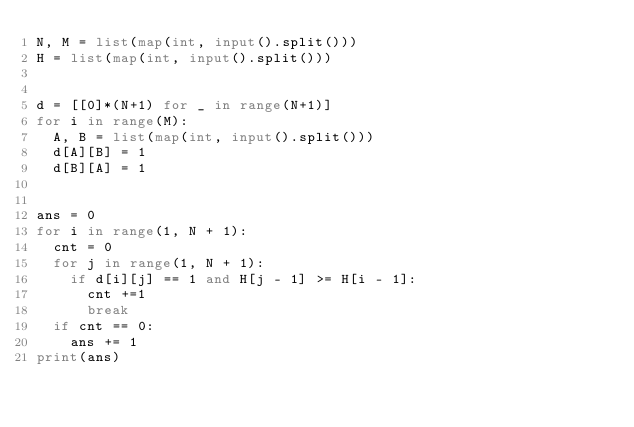<code> <loc_0><loc_0><loc_500><loc_500><_Python_>N, M = list(map(int, input().split()))
H = list(map(int, input().split()))


d = [[0]*(N+1) for _ in range(N+1)]
for i in range(M):
  A, B = list(map(int, input().split()))
  d[A][B] = 1
  d[B][A] = 1


ans = 0
for i in range(1, N + 1):
  cnt = 0
  for j in range(1, N + 1):
    if d[i][j] == 1 and H[j - 1] >= H[i - 1]:
      cnt +=1
      break
  if cnt == 0:
    ans += 1
print(ans)</code> 